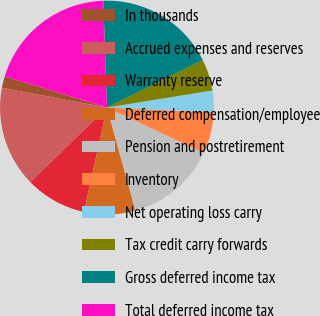Convert chart to OTSL. <chart><loc_0><loc_0><loc_500><loc_500><pie_chart><fcel>In thousands<fcel>Accrued expenses and reserves<fcel>Warranty reserve<fcel>Deferred compensation/employee<fcel>Pension and postretirement<fcel>Inventory<fcel>Net operating loss carry<fcel>Tax credit carry forwards<fcel>Gross deferred income tax<fcel>Total deferred income tax<nl><fcel>1.77%<fcel>15.24%<fcel>9.25%<fcel>7.75%<fcel>13.74%<fcel>6.26%<fcel>3.26%<fcel>4.76%<fcel>18.23%<fcel>19.73%<nl></chart> 